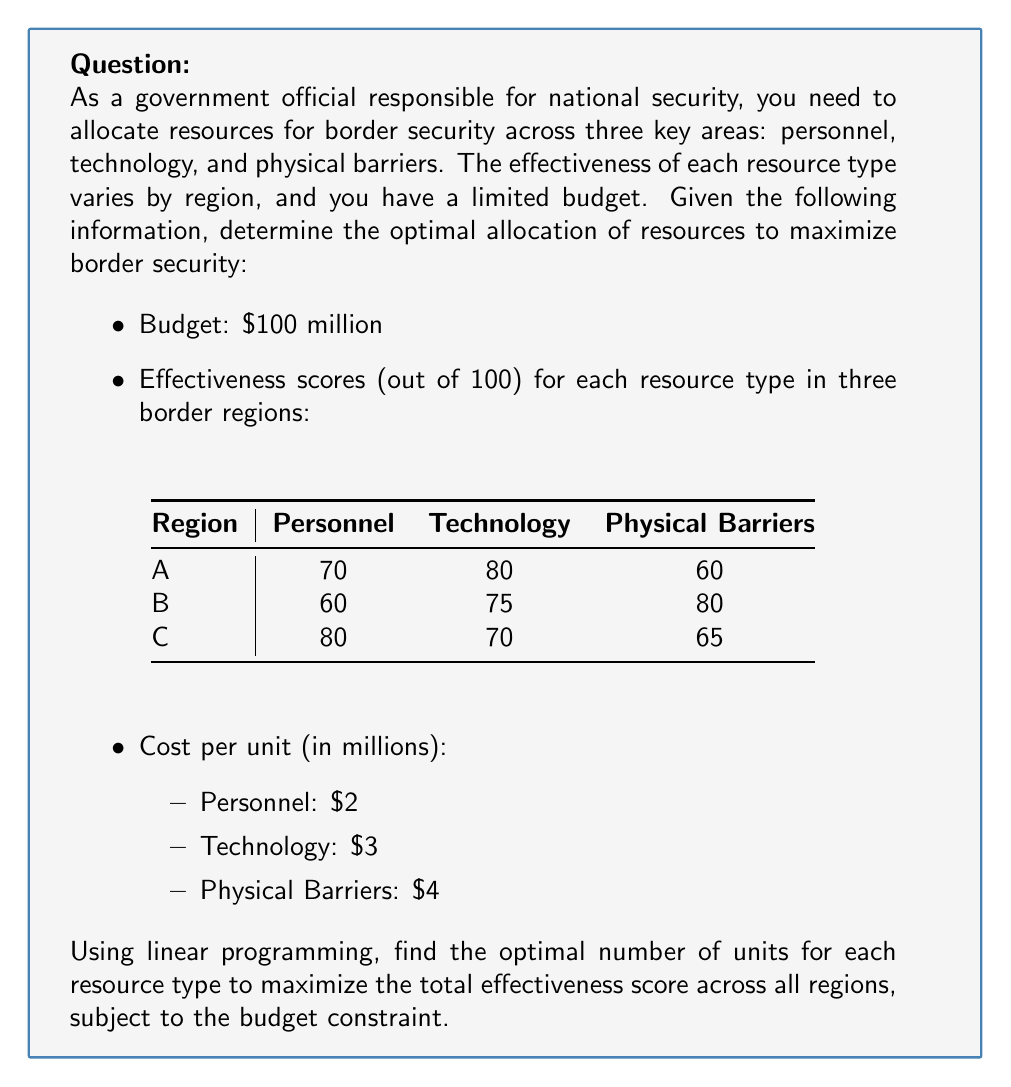Help me with this question. To solve this linear programming problem, we'll follow these steps:

1. Define variables:
   Let $x_1$, $x_2$, and $x_3$ represent the number of units for personnel, technology, and physical barriers, respectively.

2. Set up the objective function:
   We want to maximize the total effectiveness score across all regions.
   $$\text{Maximize: } Z = (70+60+80)x_1 + (80+75+70)x_2 + (60+80+65)x_3$$
   $$Z = 210x_1 + 225x_2 + 205x_3$$

3. Define constraints:
   Budget constraint: $2x_1 + 3x_2 + 4x_3 \leq 100$
   Non-negativity constraints: $x_1, x_2, x_3 \geq 0$

4. Solve using the simplex method or linear programming software:
   Using a linear programming solver, we obtain the following solution:
   $x_1 = 0$ (Personnel)
   $x_2 = 33.33$ (Technology)
   $x_3 = 0$ (Physical Barriers)

5. Calculate the maximum effectiveness score:
   $$Z = 210(0) + 225(33.33) + 205(0) = 7,499.25$$

6. Interpret the results:
   The optimal allocation is to invest all resources in technology, purchasing approximately 33 units. This yields a maximum effectiveness score of 7,499.25.
Answer: 33 units of technology; effectiveness score: 7,499.25 